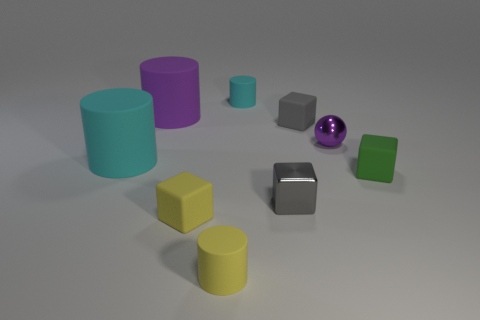Subtract all red cylinders. Subtract all red spheres. How many cylinders are left? 4 Add 1 cyan matte cylinders. How many objects exist? 10 Subtract all cylinders. How many objects are left? 5 Subtract 1 gray blocks. How many objects are left? 8 Subtract all small purple spheres. Subtract all big rubber cylinders. How many objects are left? 6 Add 8 tiny yellow matte things. How many tiny yellow matte things are left? 10 Add 5 small green rubber cubes. How many small green rubber cubes exist? 6 